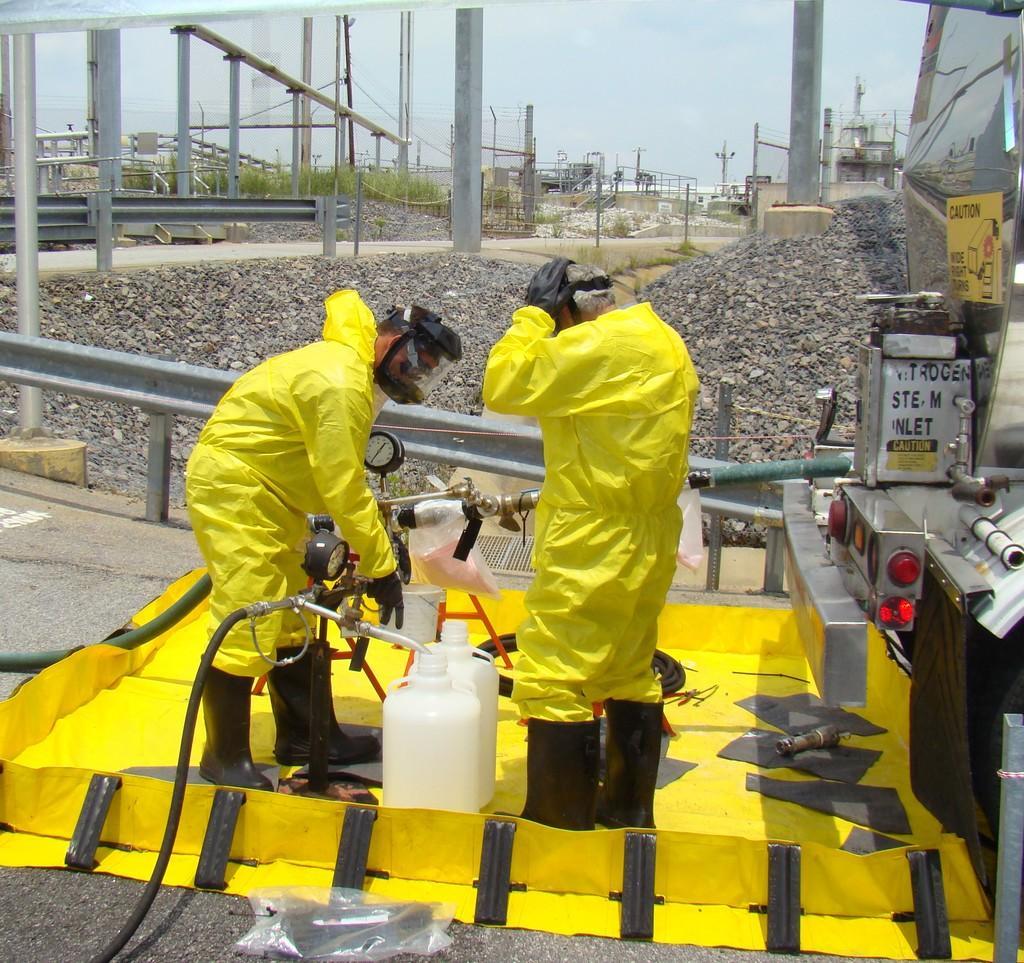How would you summarize this image in a sentence or two? In this image in the center there are two persons who are standing and they are filling some fuel in cans, and on the right side there are some machines. At the bottom there is a walkway and carpet, in the background there are some stones pillars, wires, trees. On the top of the image there is sky. 